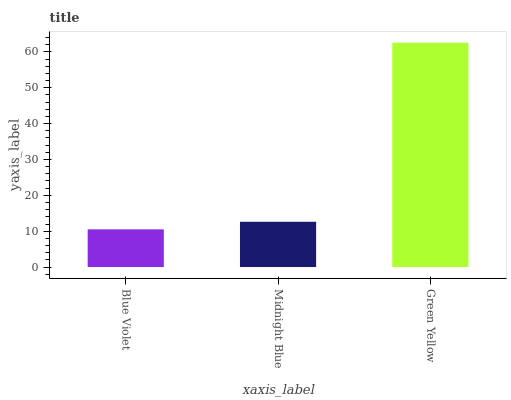Is Blue Violet the minimum?
Answer yes or no. Yes. Is Green Yellow the maximum?
Answer yes or no. Yes. Is Midnight Blue the minimum?
Answer yes or no. No. Is Midnight Blue the maximum?
Answer yes or no. No. Is Midnight Blue greater than Blue Violet?
Answer yes or no. Yes. Is Blue Violet less than Midnight Blue?
Answer yes or no. Yes. Is Blue Violet greater than Midnight Blue?
Answer yes or no. No. Is Midnight Blue less than Blue Violet?
Answer yes or no. No. Is Midnight Blue the high median?
Answer yes or no. Yes. Is Midnight Blue the low median?
Answer yes or no. Yes. Is Green Yellow the high median?
Answer yes or no. No. Is Blue Violet the low median?
Answer yes or no. No. 